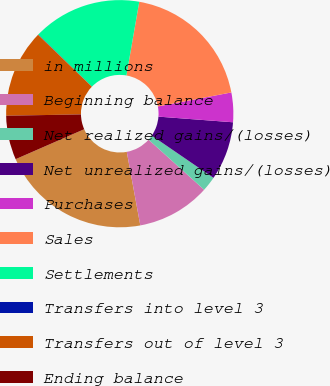<chart> <loc_0><loc_0><loc_500><loc_500><pie_chart><fcel>in millions<fcel>Beginning balance<fcel>Net realized gains/(losses)<fcel>Net unrealized gains/(losses)<fcel>Purchases<fcel>Sales<fcel>Settlements<fcel>Transfers into level 3<fcel>Transfers out of level 3<fcel>Ending balance<nl><fcel>21.34%<fcel>10.43%<fcel>2.12%<fcel>8.35%<fcel>4.2%<fcel>19.26%<fcel>15.48%<fcel>0.04%<fcel>12.51%<fcel>6.27%<nl></chart> 